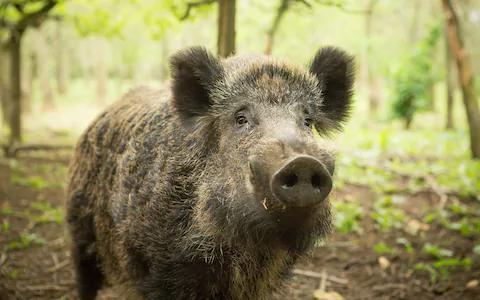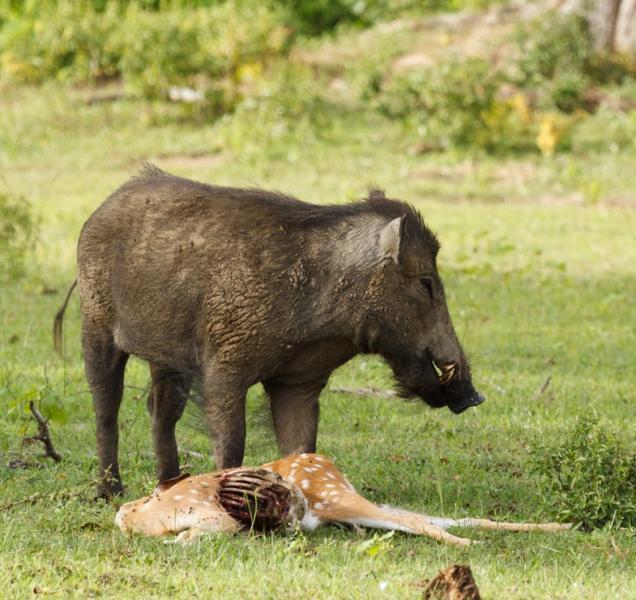The first image is the image on the left, the second image is the image on the right. Analyze the images presented: Is the assertion "An image shows at least one wild pig standing by a carcass." valid? Answer yes or no. Yes. The first image is the image on the left, the second image is the image on the right. For the images shown, is this caption "One images shows a human in close proximity to two boars." true? Answer yes or no. No. 